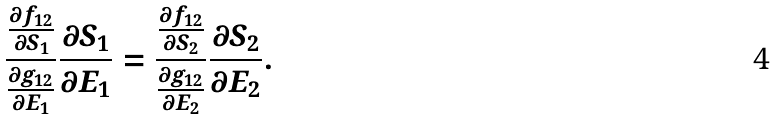Convert formula to latex. <formula><loc_0><loc_0><loc_500><loc_500>\frac { \frac { \partial f _ { 1 2 } } { \partial S _ { 1 } } } { \frac { \partial g _ { 1 2 } } { \partial E _ { 1 } } } \frac { \partial S _ { 1 } } { \partial E _ { 1 } } = \frac { \frac { \partial f _ { 1 2 } } { \partial S _ { 2 } } } { \frac { \partial g _ { 1 2 } } { \partial E _ { 2 } } } \frac { \partial S _ { 2 } } { \partial E _ { 2 } } .</formula> 